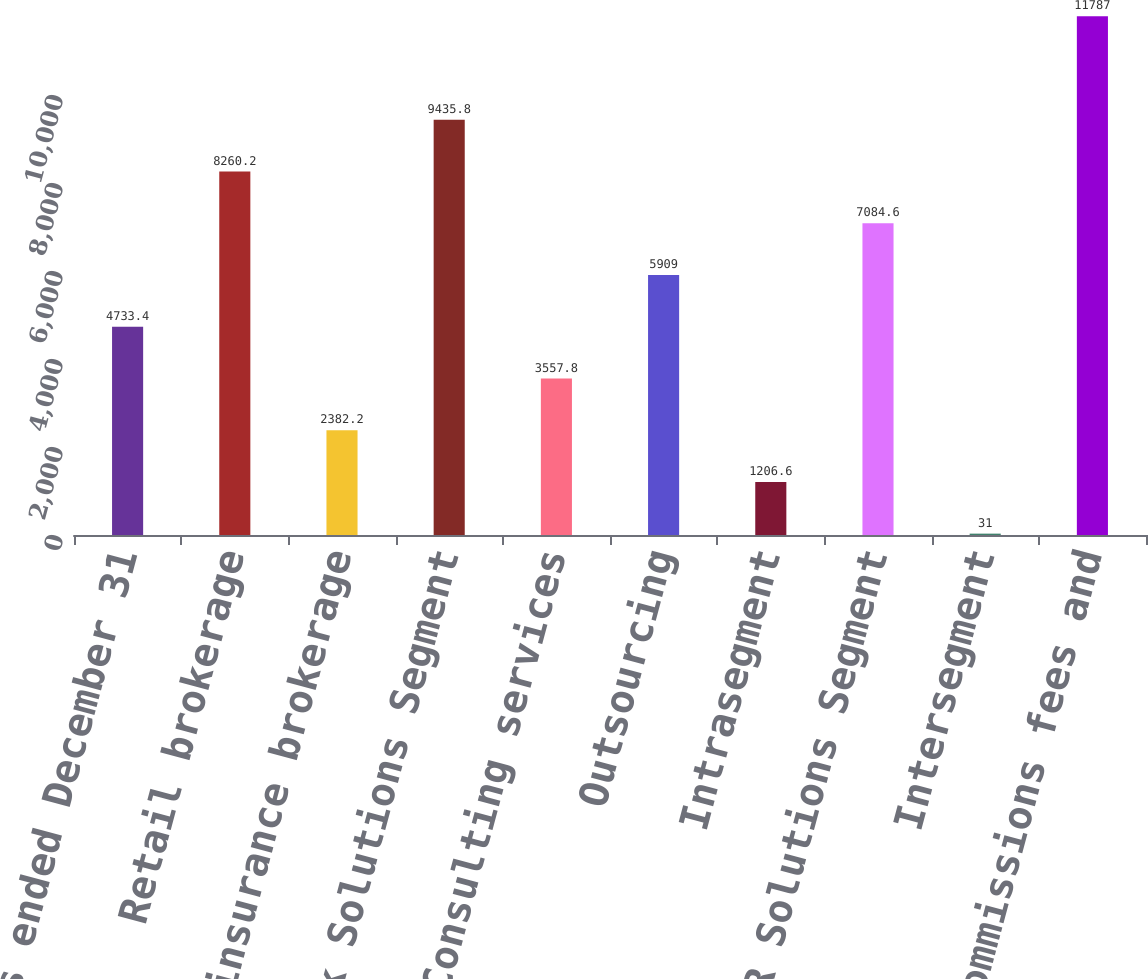<chart> <loc_0><loc_0><loc_500><loc_500><bar_chart><fcel>Years ended December 31<fcel>Retail brokerage<fcel>Reinsurance brokerage<fcel>Total Risk Solutions Segment<fcel>Consulting services<fcel>Outsourcing<fcel>Intrasegment<fcel>Total HR Solutions Segment<fcel>Intersegment<fcel>Total commissions fees and<nl><fcel>4733.4<fcel>8260.2<fcel>2382.2<fcel>9435.8<fcel>3557.8<fcel>5909<fcel>1206.6<fcel>7084.6<fcel>31<fcel>11787<nl></chart> 